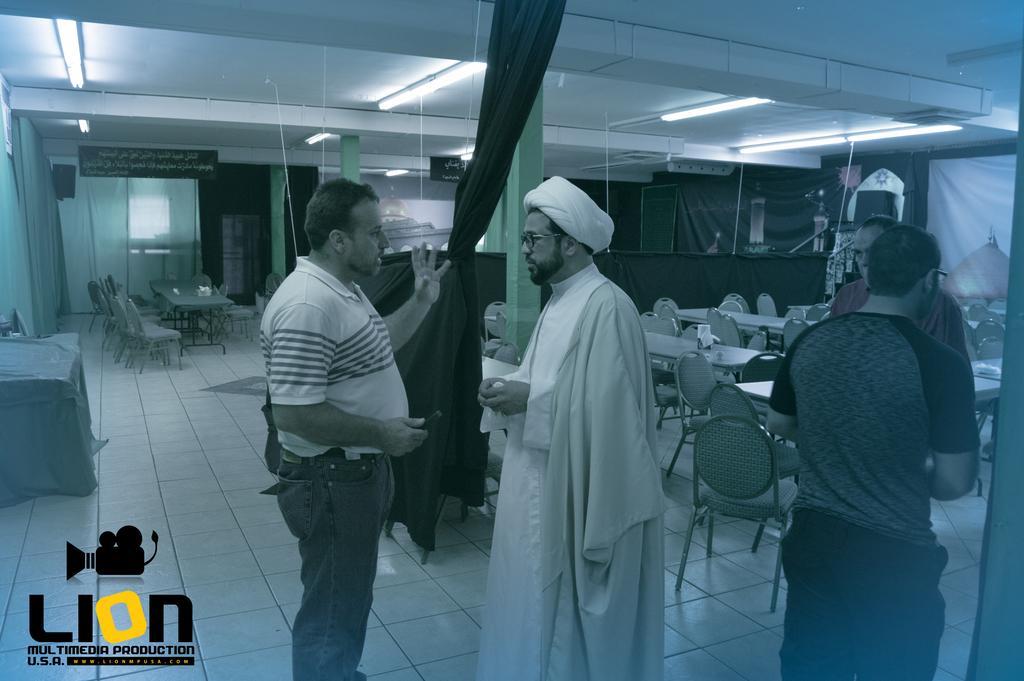Could you give a brief overview of what you see in this image? In this picture, we can see a few people, we can see the ground with some objects on it like tables, chairs, and we can see the wall with posters and some objects attached to it, we can see curtains, and the roof with lights, some objects attached to it. 